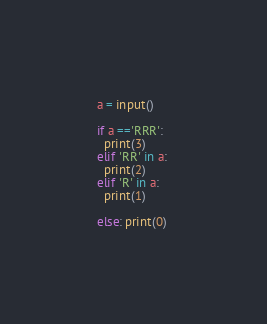Convert code to text. <code><loc_0><loc_0><loc_500><loc_500><_Python_>a = input()

if a =='RRR':
  print(3)
elif 'RR' in a: 
  print(2)
elif 'R' in a: 
  print(1)

else: print(0)

</code> 